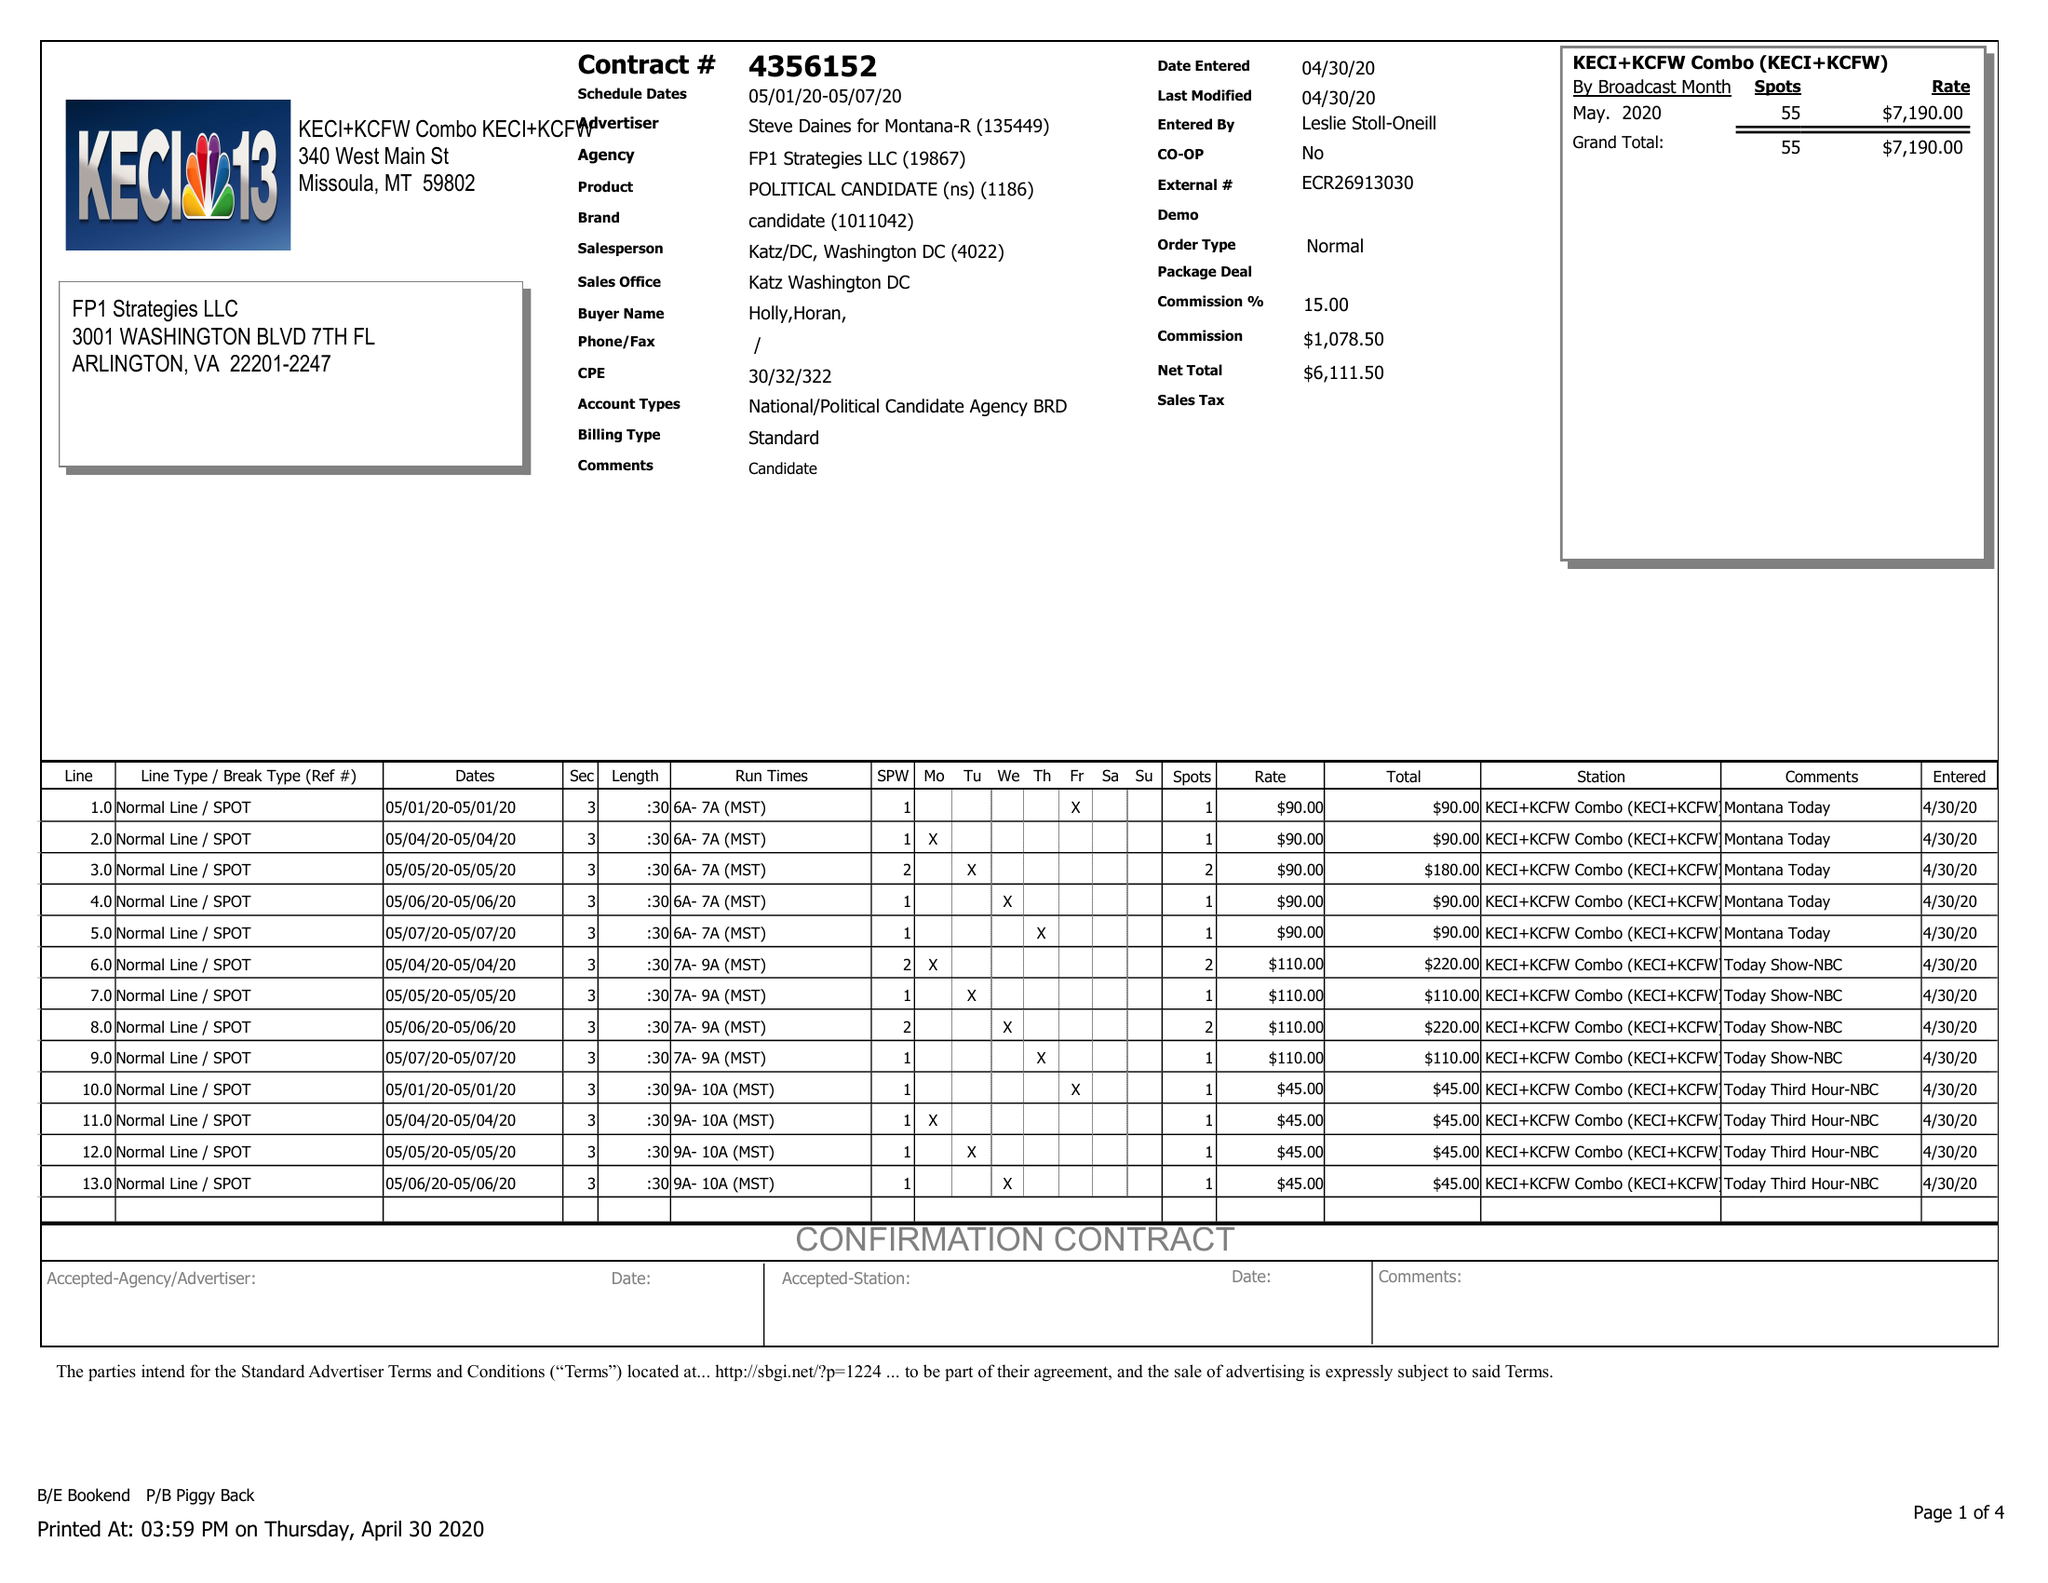What is the value for the advertiser?
Answer the question using a single word or phrase. STEVE DAINES FOR MONTANA-R 